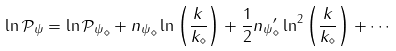<formula> <loc_0><loc_0><loc_500><loc_500>\ln \mathcal { P _ { \psi } } = \ln \mathcal { P _ { \psi } } _ { \diamond } + { n _ { \psi } } _ { \diamond } \ln \left ( \frac { k } { k _ { \diamond } } \right ) + \frac { 1 } { 2 } { n _ { \psi } } ^ { \prime } _ { \diamond } \ln ^ { 2 } \left ( \frac { k } { k _ { \diamond } } \right ) + \cdots</formula> 